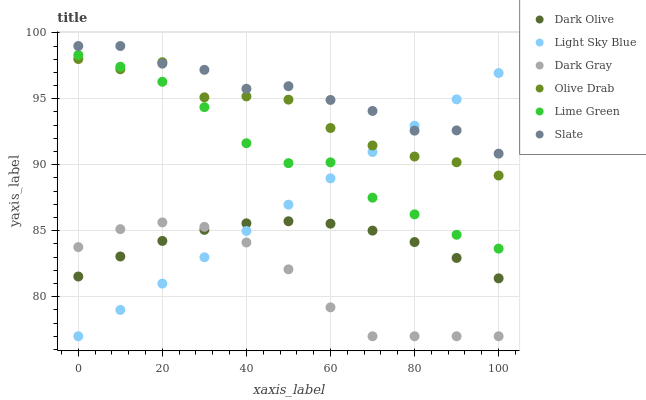Does Dark Gray have the minimum area under the curve?
Answer yes or no. Yes. Does Slate have the maximum area under the curve?
Answer yes or no. Yes. Does Dark Olive have the minimum area under the curve?
Answer yes or no. No. Does Dark Olive have the maximum area under the curve?
Answer yes or no. No. Is Light Sky Blue the smoothest?
Answer yes or no. Yes. Is Olive Drab the roughest?
Answer yes or no. Yes. Is Dark Olive the smoothest?
Answer yes or no. No. Is Dark Olive the roughest?
Answer yes or no. No. Does Dark Gray have the lowest value?
Answer yes or no. Yes. Does Dark Olive have the lowest value?
Answer yes or no. No. Does Slate have the highest value?
Answer yes or no. Yes. Does Dark Olive have the highest value?
Answer yes or no. No. Is Dark Gray less than Lime Green?
Answer yes or no. Yes. Is Lime Green greater than Dark Olive?
Answer yes or no. Yes. Does Dark Olive intersect Dark Gray?
Answer yes or no. Yes. Is Dark Olive less than Dark Gray?
Answer yes or no. No. Is Dark Olive greater than Dark Gray?
Answer yes or no. No. Does Dark Gray intersect Lime Green?
Answer yes or no. No. 